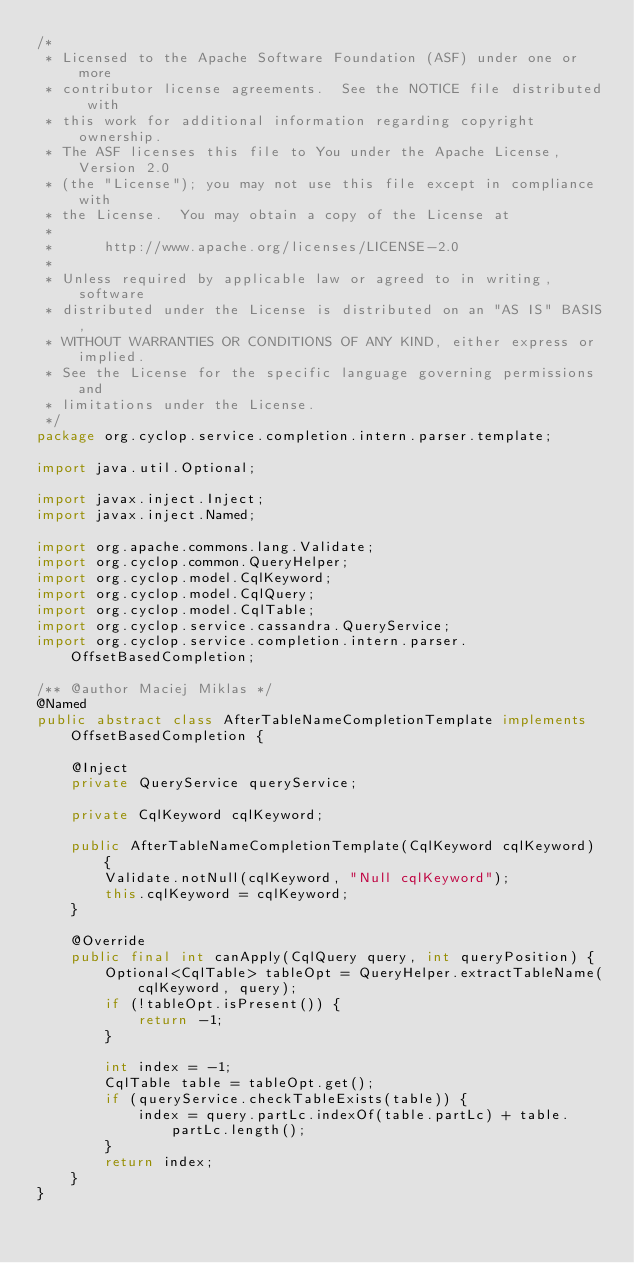Convert code to text. <code><loc_0><loc_0><loc_500><loc_500><_Java_>/*
 * Licensed to the Apache Software Foundation (ASF) under one or more
 * contributor license agreements.  See the NOTICE file distributed with
 * this work for additional information regarding copyright ownership.
 * The ASF licenses this file to You under the Apache License, Version 2.0
 * (the "License"); you may not use this file except in compliance with
 * the License.  You may obtain a copy of the License at
 *
 *      http://www.apache.org/licenses/LICENSE-2.0
 *
 * Unless required by applicable law or agreed to in writing, software
 * distributed under the License is distributed on an "AS IS" BASIS,
 * WITHOUT WARRANTIES OR CONDITIONS OF ANY KIND, either express or implied.
 * See the License for the specific language governing permissions and
 * limitations under the License.
 */
package org.cyclop.service.completion.intern.parser.template;

import java.util.Optional;

import javax.inject.Inject;
import javax.inject.Named;

import org.apache.commons.lang.Validate;
import org.cyclop.common.QueryHelper;
import org.cyclop.model.CqlKeyword;
import org.cyclop.model.CqlQuery;
import org.cyclop.model.CqlTable;
import org.cyclop.service.cassandra.QueryService;
import org.cyclop.service.completion.intern.parser.OffsetBasedCompletion;

/** @author Maciej Miklas */
@Named
public abstract class AfterTableNameCompletionTemplate implements OffsetBasedCompletion {

	@Inject
	private QueryService queryService;

	private CqlKeyword cqlKeyword;

	public AfterTableNameCompletionTemplate(CqlKeyword cqlKeyword) {
		Validate.notNull(cqlKeyword, "Null cqlKeyword");
		this.cqlKeyword = cqlKeyword;
	}

	@Override
	public final int canApply(CqlQuery query, int queryPosition) {
		Optional<CqlTable> tableOpt = QueryHelper.extractTableName(cqlKeyword, query);
		if (!tableOpt.isPresent()) {
			return -1;
		}

		int index = -1;
		CqlTable table = tableOpt.get();
		if (queryService.checkTableExists(table)) {
			index = query.partLc.indexOf(table.partLc) + table.partLc.length();
		}
		return index;
	}
}
</code> 